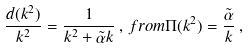<formula> <loc_0><loc_0><loc_500><loc_500>\frac { d ( k ^ { 2 } ) } { k ^ { 2 } } = \frac { 1 } { k ^ { 2 } + \tilde { \alpha } k } \, , \, f r o m \Pi ( k ^ { 2 } ) = \frac { \tilde { \alpha } } { k } \, ,</formula> 